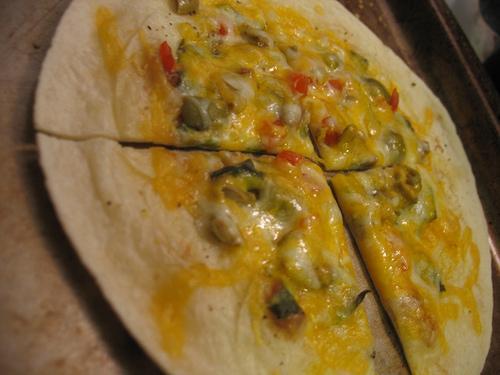How many pieces of food are on the tray?
Give a very brief answer. 1. How many different kinds of vegetables are on the food?
Give a very brief answer. 2. 